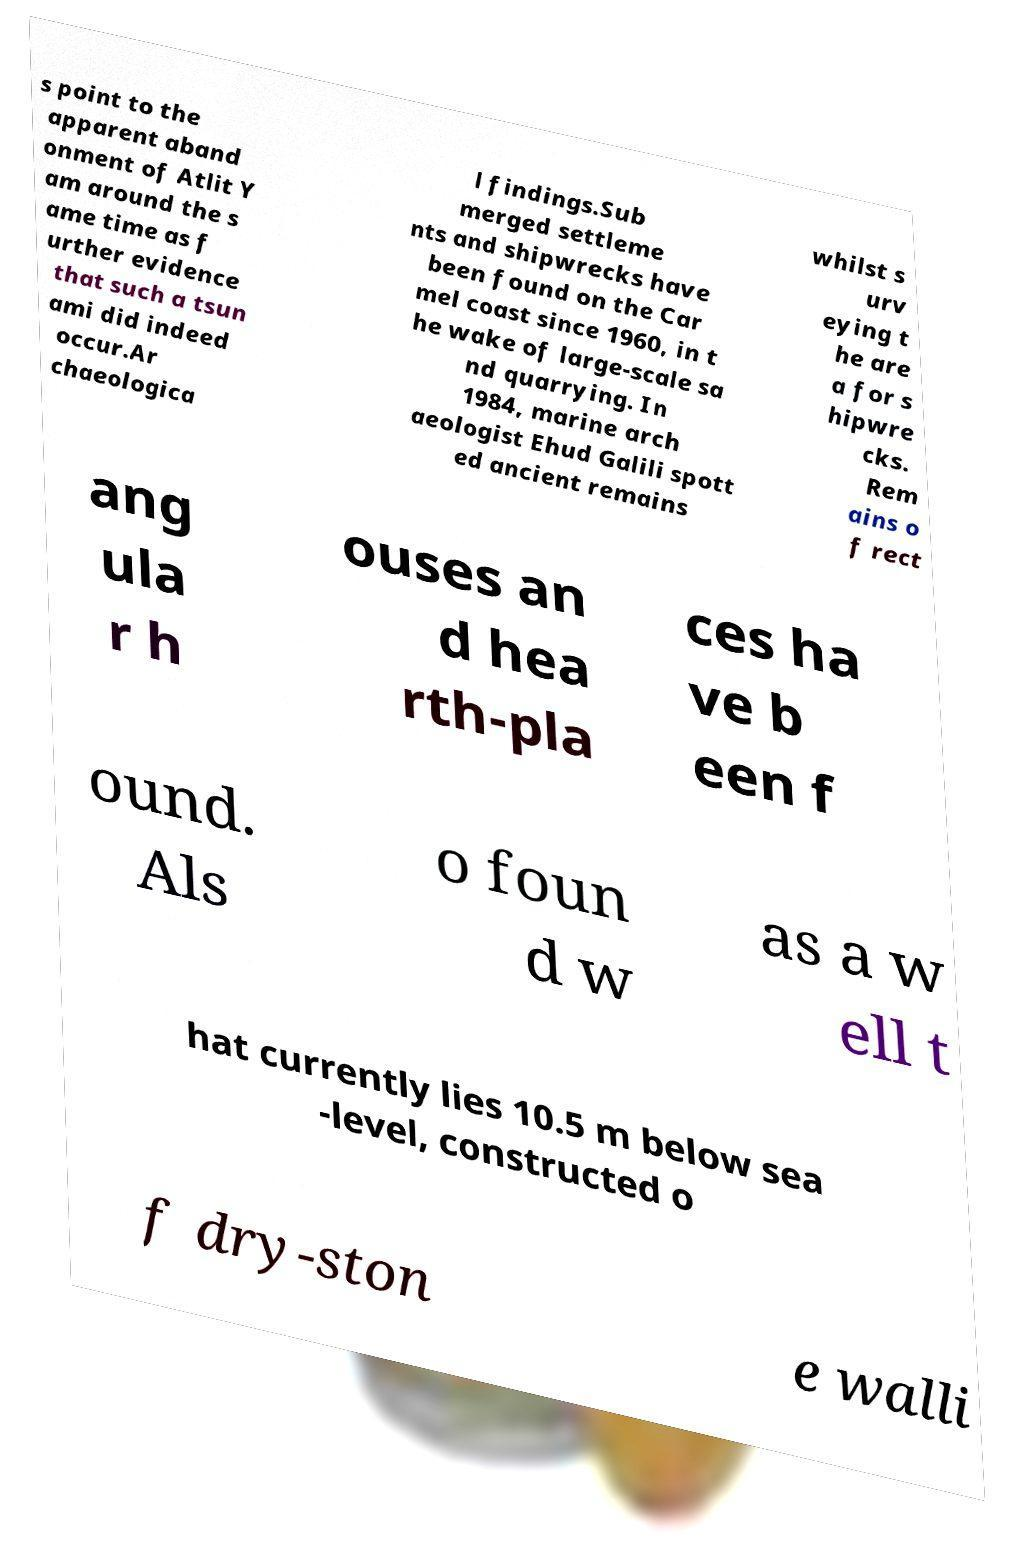Please identify and transcribe the text found in this image. s point to the apparent aband onment of Atlit Y am around the s ame time as f urther evidence that such a tsun ami did indeed occur.Ar chaeologica l findings.Sub merged settleme nts and shipwrecks have been found on the Car mel coast since 1960, in t he wake of large-scale sa nd quarrying. In 1984, marine arch aeologist Ehud Galili spott ed ancient remains whilst s urv eying t he are a for s hipwre cks. Rem ains o f rect ang ula r h ouses an d hea rth-pla ces ha ve b een f ound. Als o foun d w as a w ell t hat currently lies 10.5 m below sea -level, constructed o f dry-ston e walli 